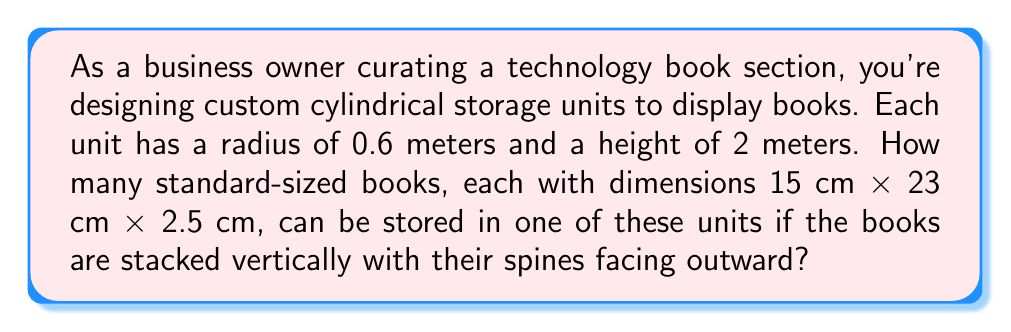Can you solve this math problem? Let's approach this step-by-step:

1) First, we need to calculate the volume of the cylindrical storage unit:
   $$V_{cylinder} = \pi r^2 h$$
   where $r$ is the radius and $h$ is the height.
   $$V_{cylinder} = \pi \cdot (0.6\text{ m})^2 \cdot 2\text{ m} = 2.26\text{ m}^3$$

2) Next, we calculate the volume of a single book:
   $$V_{book} = 15\text{ cm} \times 23\text{ cm} \times 2.5\text{ cm} = 862.5\text{ cm}^3 = 0.0008625\text{ m}^3$$

3) To find how many books can fit, we divide the volume of the cylinder by the volume of a book:
   $$\text{Number of books} = \frac{V_{cylinder}}{V_{book}} = \frac{2.26\text{ m}^3}{0.0008625\text{ m}^3} \approx 2619.35$$

4) However, this assumes perfect packing, which isn't realistic. We need to consider the circular shape of the cylinder and how books would be arranged.

5) The circumference of the base is:
   $$C = 2\pi r = 2\pi \cdot 0.6\text{ m} = 3.77\text{ m}$$

6) The number of books that can fit around the circumference is:
   $$\frac{3.77\text{ m}}{0.025\text{ m}} \approx 150.8$$
   We round down to 150 books per layer.

7) The number of layers we can stack vertically is:
   $$\frac{2\text{ m}}{0.15\text{ m}} \approx 13.33$$
   We round down to 13 layers.

8) Therefore, the total number of books that can be stored is:
   $$150 \text{ books/layer} \times 13 \text{ layers} = 1950 \text{ books}$$
Answer: 1950 books 